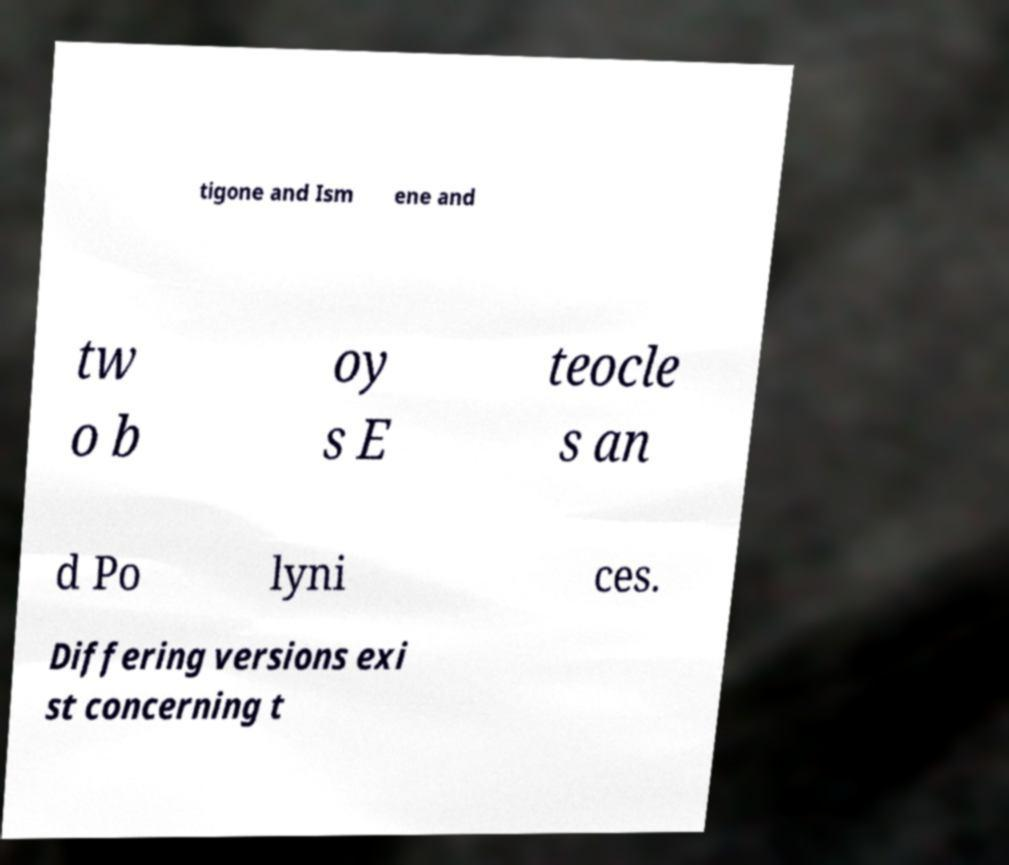I need the written content from this picture converted into text. Can you do that? tigone and Ism ene and tw o b oy s E teocle s an d Po lyni ces. Differing versions exi st concerning t 